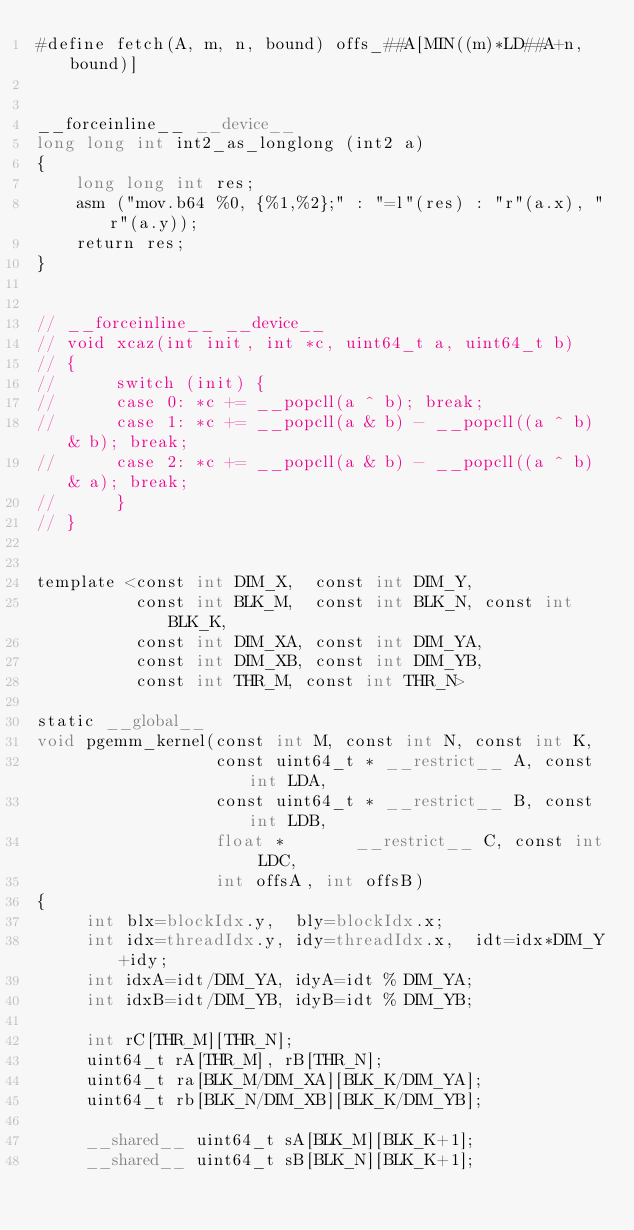Convert code to text. <code><loc_0><loc_0><loc_500><loc_500><_Cuda_>#define fetch(A, m, n, bound) offs_##A[MIN((m)*LD##A+n, bound)]


__forceinline__ __device__
long long int int2_as_longlong (int2 a)
{
    long long int res;
    asm ("mov.b64 %0, {%1,%2};" : "=l"(res) : "r"(a.x), "r"(a.y));
    return res;
}


// __forceinline__ __device__
// void xcaz(int init, int *c, uint64_t a, uint64_t b)
// {
//      switch (init) {
//      case 0: *c += __popcll(a ^ b); break;
//      case 1: *c += __popcll(a & b) - __popcll((a ^ b) & b); break;
//      case 2: *c += __popcll(a & b) - __popcll((a ^ b) & a); break;
//      }
// }


template <const int DIM_X,  const int DIM_Y,
          const int BLK_M,  const int BLK_N, const int BLK_K,
          const int DIM_XA, const int DIM_YA,
          const int DIM_XB, const int DIM_YB,
          const int THR_M, const int THR_N>

static __global__
void pgemm_kernel(const int M, const int N, const int K,
                  const uint64_t * __restrict__ A, const int LDA,
                  const uint64_t * __restrict__ B, const int LDB,
                  float *       __restrict__ C, const int LDC,
                  int offsA, int offsB)
{
     int blx=blockIdx.y,  bly=blockIdx.x;
     int idx=threadIdx.y, idy=threadIdx.x,  idt=idx*DIM_Y+idy;
     int idxA=idt/DIM_YA, idyA=idt % DIM_YA;
     int idxB=idt/DIM_YB, idyB=idt % DIM_YB;

     int rC[THR_M][THR_N];
     uint64_t rA[THR_M], rB[THR_N];
     uint64_t ra[BLK_M/DIM_XA][BLK_K/DIM_YA];
     uint64_t rb[BLK_N/DIM_XB][BLK_K/DIM_YB];

     __shared__ uint64_t sA[BLK_M][BLK_K+1];
     __shared__ uint64_t sB[BLK_N][BLK_K+1];

</code> 